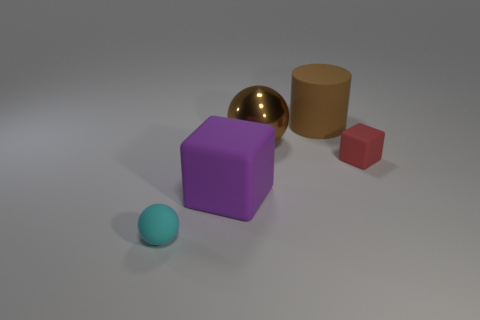Subtract all purple cubes. How many cubes are left? 1 Add 1 large brown balls. How many objects exist? 6 Subtract all balls. How many objects are left? 3 Subtract 0 purple balls. How many objects are left? 5 Subtract all red blocks. Subtract all large brown cylinders. How many objects are left? 3 Add 1 brown matte objects. How many brown matte objects are left? 2 Add 1 green metal objects. How many green metal objects exist? 1 